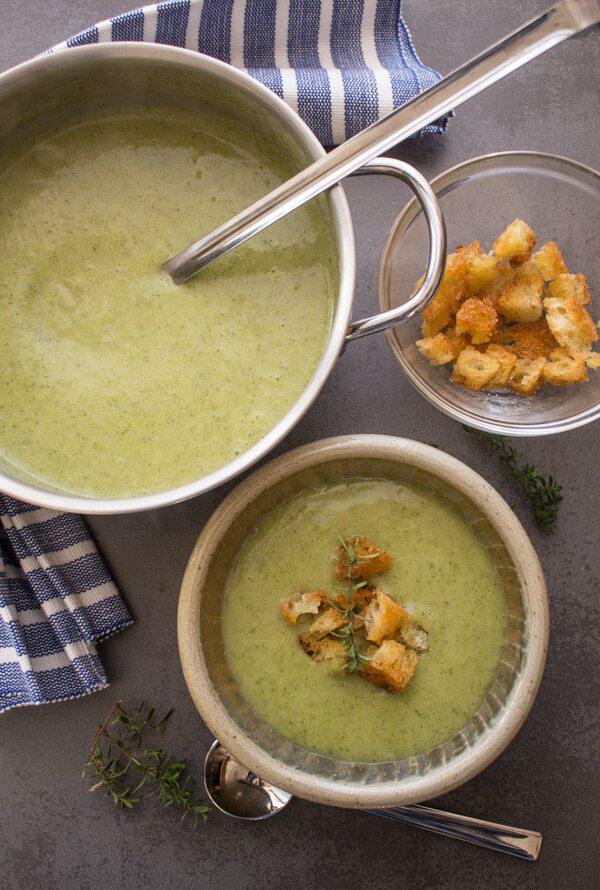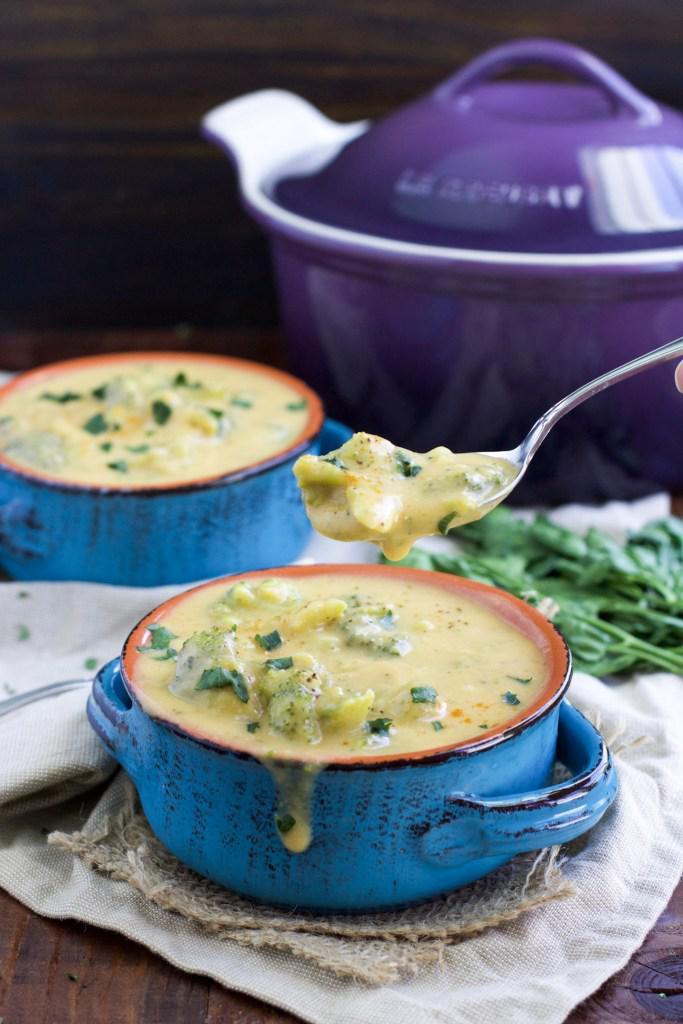The first image is the image on the left, the second image is the image on the right. For the images shown, is this caption "there is exactly one bowl with a spoon in it in the image on the right" true? Answer yes or no. No. The first image is the image on the left, the second image is the image on the right. Examine the images to the left and right. Is the description "Right image shows creamy soup with colorful garnish and bread nearby." accurate? Answer yes or no. No. 